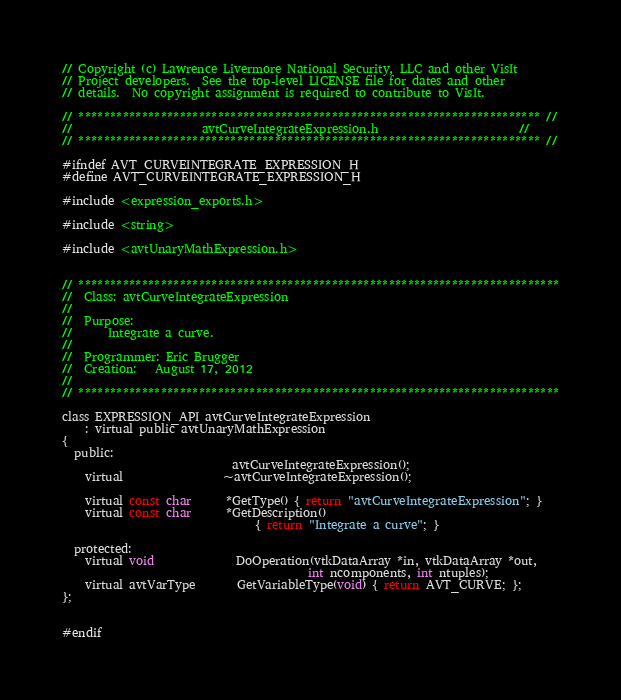Convert code to text. <code><loc_0><loc_0><loc_500><loc_500><_C_>// Copyright (c) Lawrence Livermore National Security, LLC and other VisIt
// Project developers.  See the top-level LICENSE file for dates and other
// details.  No copyright assignment is required to contribute to VisIt.

// ************************************************************************* //
//                      avtCurveIntegrateExpression.h                        //
// ************************************************************************* //

#ifndef AVT_CURVEINTEGRATE_EXPRESSION_H
#define AVT_CURVEINTEGRATE_EXPRESSION_H

#include <expression_exports.h>

#include <string>

#include <avtUnaryMathExpression.h>


// ****************************************************************************
//  Class: avtCurveIntegrateExpression
//
//  Purpose:
//      Integrate a curve.
//
//  Programmer: Eric Brugger
//  Creation:   August 17, 2012
//
// ****************************************************************************

class EXPRESSION_API avtCurveIntegrateExpression 
    : virtual public avtUnaryMathExpression
{
  public:
                             avtCurveIntegrateExpression();
    virtual                 ~avtCurveIntegrateExpression();

    virtual const char      *GetType() { return "avtCurveIntegrateExpression"; }
    virtual const char      *GetDescription() 
                                 { return "Integrate a curve"; }

  protected:
    virtual void              DoOperation(vtkDataArray *in, vtkDataArray *out,
                                          int ncomponents, int ntuples);
    virtual avtVarType       GetVariableType(void) { return AVT_CURVE; };
};


#endif
</code> 